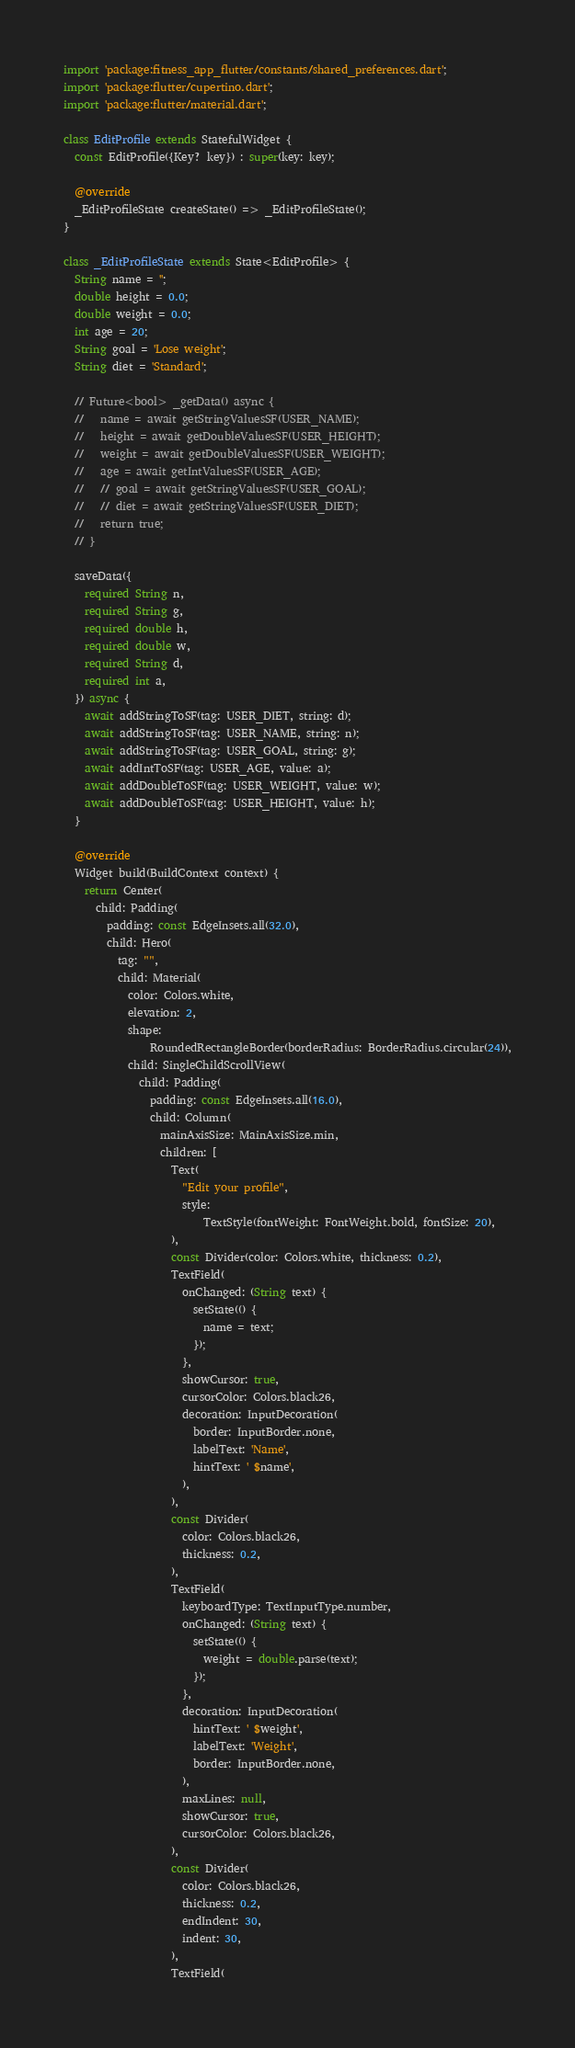<code> <loc_0><loc_0><loc_500><loc_500><_Dart_>import 'package:fitness_app_flutter/constants/shared_preferences.dart';
import 'package:flutter/cupertino.dart';
import 'package:flutter/material.dart';

class EditProfile extends StatefulWidget {
  const EditProfile({Key? key}) : super(key: key);

  @override
  _EditProfileState createState() => _EditProfileState();
}

class _EditProfileState extends State<EditProfile> {
  String name = '';
  double height = 0.0;
  double weight = 0.0;
  int age = 20;
  String goal = 'Lose weight';
  String diet = 'Standard';

  // Future<bool> _getData() async {
  //   name = await getStringValuesSF(USER_NAME);
  //   height = await getDoubleValuesSF(USER_HEIGHT);
  //   weight = await getDoubleValuesSF(USER_WEIGHT);
  //   age = await getIntValuesSF(USER_AGE);
  //   // goal = await getStringValuesSF(USER_GOAL);
  //   // diet = await getStringValuesSF(USER_DIET);
  //   return true;
  // }

  saveData({
    required String n,
    required String g,
    required double h,
    required double w,
    required String d,
    required int a,
  }) async {
    await addStringToSF(tag: USER_DIET, string: d);
    await addStringToSF(tag: USER_NAME, string: n);
    await addStringToSF(tag: USER_GOAL, string: g);
    await addIntToSF(tag: USER_AGE, value: a);
    await addDoubleToSF(tag: USER_WEIGHT, value: w);
    await addDoubleToSF(tag: USER_HEIGHT, value: h);
  }

  @override
  Widget build(BuildContext context) {
    return Center(
      child: Padding(
        padding: const EdgeInsets.all(32.0),
        child: Hero(
          tag: "",
          child: Material(
            color: Colors.white,
            elevation: 2,
            shape:
                RoundedRectangleBorder(borderRadius: BorderRadius.circular(24)),
            child: SingleChildScrollView(
              child: Padding(
                padding: const EdgeInsets.all(16.0),
                child: Column(
                  mainAxisSize: MainAxisSize.min,
                  children: [
                    Text(
                      "Edit your profile",
                      style:
                          TextStyle(fontWeight: FontWeight.bold, fontSize: 20),
                    ),
                    const Divider(color: Colors.white, thickness: 0.2),
                    TextField(
                      onChanged: (String text) {
                        setState(() {
                          name = text;
                        });
                      },
                      showCursor: true,
                      cursorColor: Colors.black26,
                      decoration: InputDecoration(
                        border: InputBorder.none,
                        labelText: 'Name',
                        hintText: ' $name',
                      ),
                    ),
                    const Divider(
                      color: Colors.black26,
                      thickness: 0.2,
                    ),
                    TextField(
                      keyboardType: TextInputType.number,
                      onChanged: (String text) {
                        setState(() {
                          weight = double.parse(text);
                        });
                      },
                      decoration: InputDecoration(
                        hintText: ' $weight',
                        labelText: 'Weight',
                        border: InputBorder.none,
                      ),
                      maxLines: null,
                      showCursor: true,
                      cursorColor: Colors.black26,
                    ),
                    const Divider(
                      color: Colors.black26,
                      thickness: 0.2,
                      endIndent: 30,
                      indent: 30,
                    ),
                    TextField(</code> 